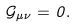<formula> <loc_0><loc_0><loc_500><loc_500>\mathcal { G } _ { \mu \nu } = 0 .</formula> 